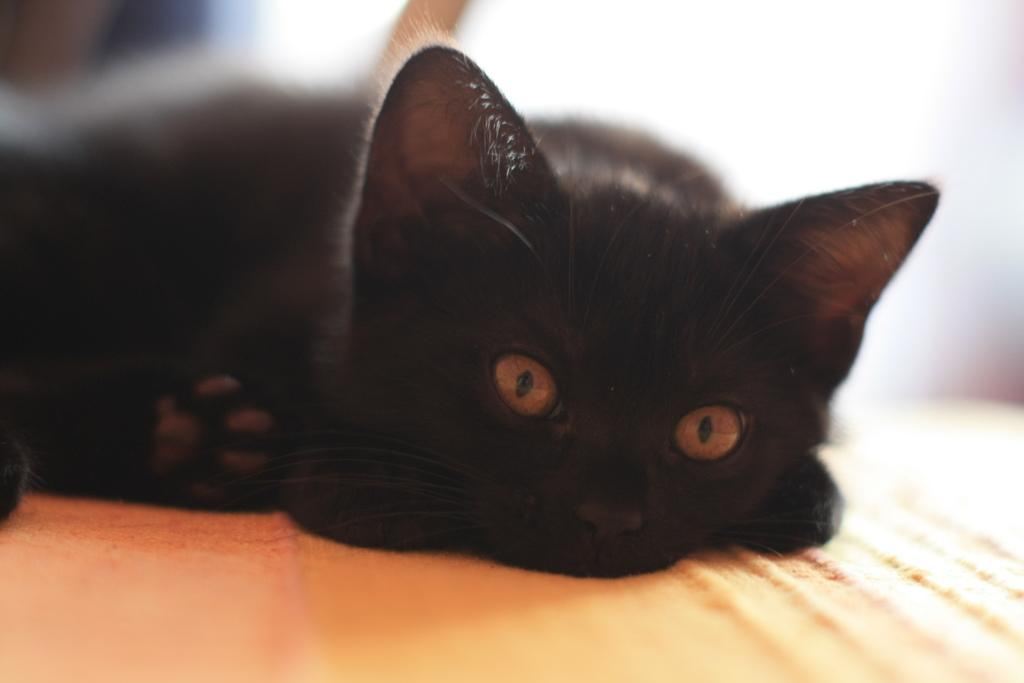What type of animal is in the image? There is a black cat in the image. What is the cat lying on? The cat is lying on an orange cloth. What is the cat's behavior in the image? The cat is looking at the camera. How would you describe the background of the image? The background of the image is blurred. What type of music is the cat playing in the image? There is no music or instrument present in the image, so the cat cannot be playing any music. 